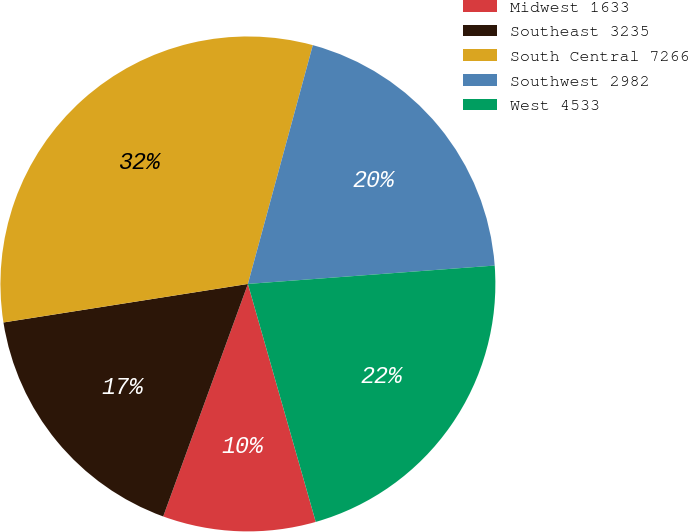Convert chart to OTSL. <chart><loc_0><loc_0><loc_500><loc_500><pie_chart><fcel>Midwest 1633<fcel>Southeast 3235<fcel>South Central 7266<fcel>Southwest 2982<fcel>West 4533<nl><fcel>9.98%<fcel>16.95%<fcel>31.71%<fcel>19.59%<fcel>21.76%<nl></chart> 